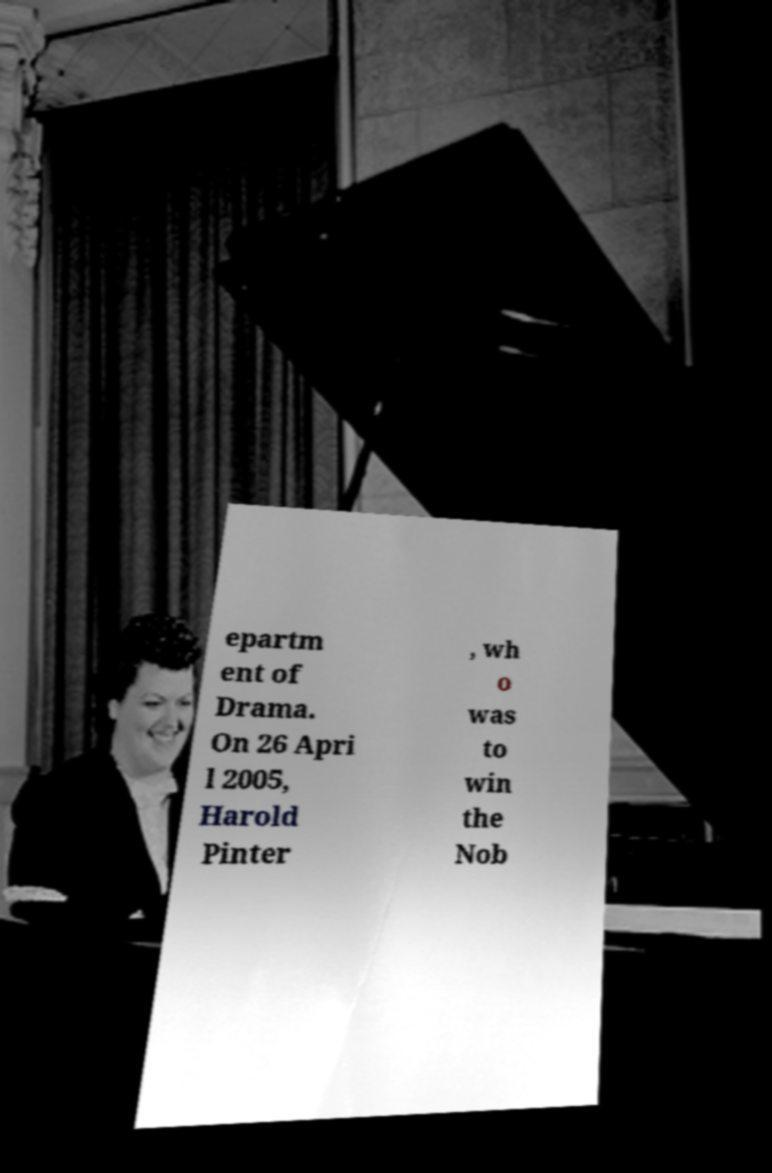For documentation purposes, I need the text within this image transcribed. Could you provide that? epartm ent of Drama. On 26 Apri l 2005, Harold Pinter , wh o was to win the Nob 